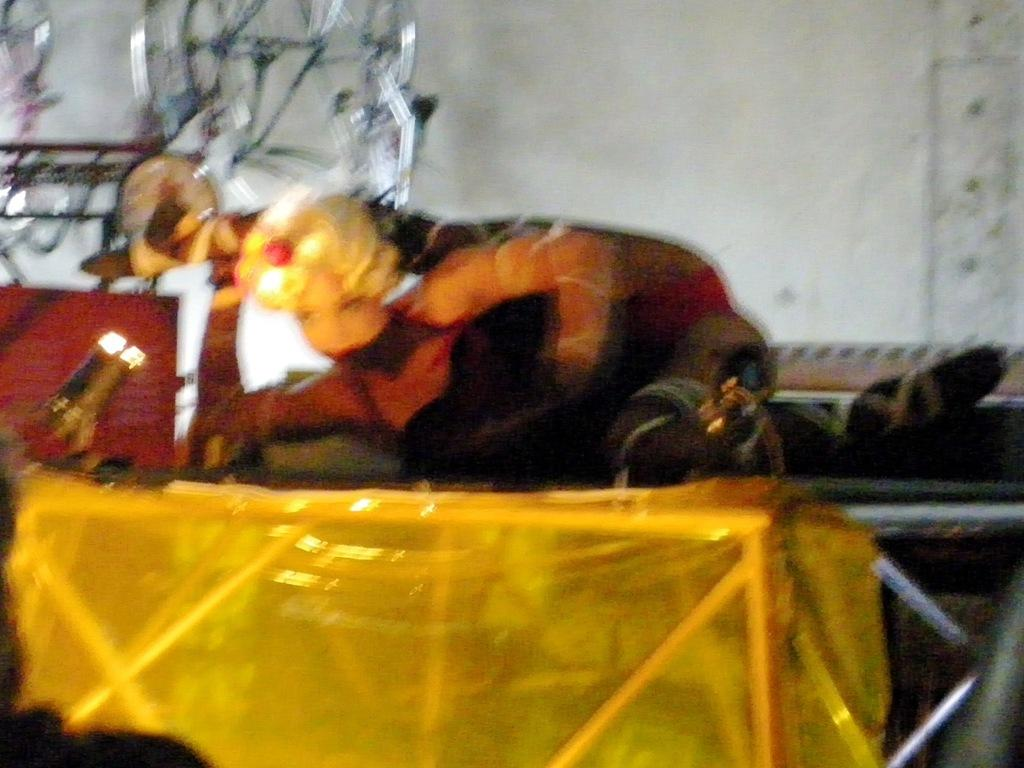Who is present in the image? There is a lady in the image. Where is the lady located? The lady is on a platform. What can be seen in the background of the image? There is a wall in the background of the image. What is the source of light in the image? There is a light on the left side of the image. Can you describe any other objects in the image? There are other unspecified objects in the image. How many dolls are wearing a crown in the image? There are no dolls or crowns present in the image. What type of kittens can be seen playing with the lady on the platform? There are no kittens present in the image. 